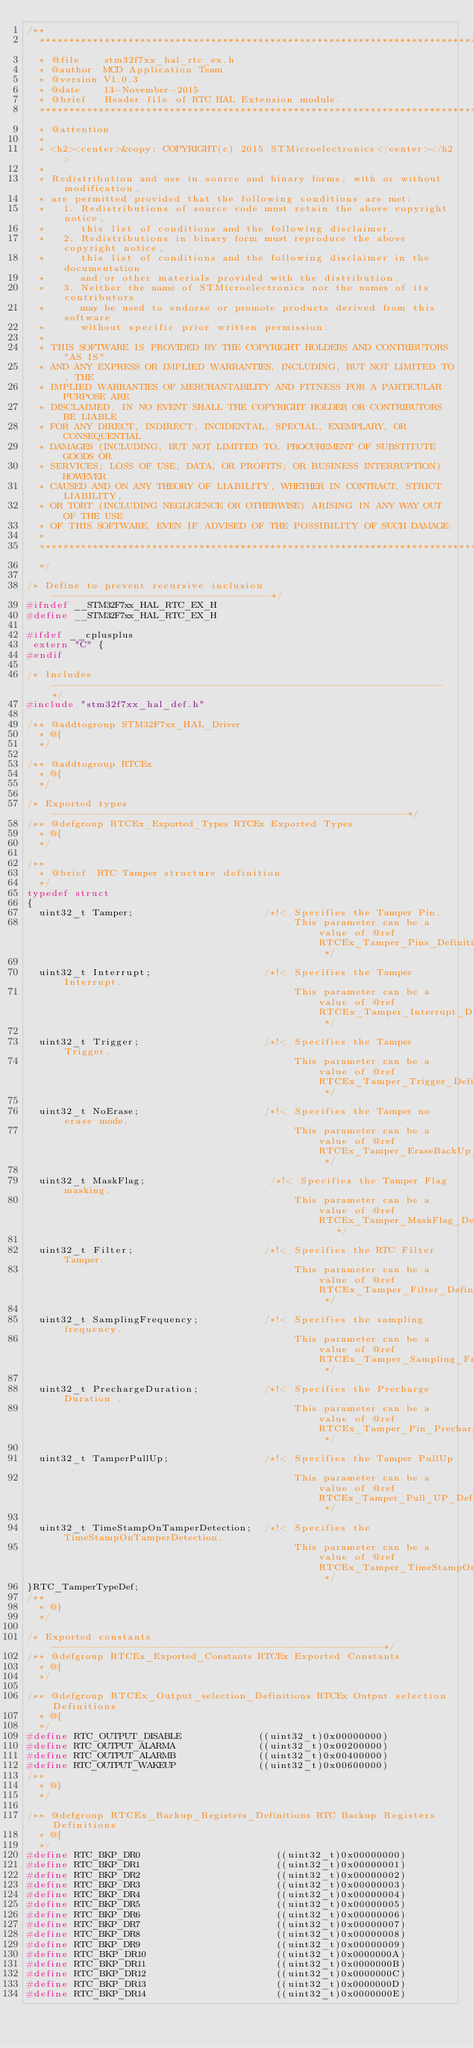<code> <loc_0><loc_0><loc_500><loc_500><_C_>/**
  ******************************************************************************
  * @file    stm32f7xx_hal_rtc_ex.h
  * @author  MCD Application Team
  * @version V1.0.3
  * @date    13-November-2015
  * @brief   Header file of RTC HAL Extension module.
  ******************************************************************************
  * @attention
  *
  * <h2><center>&copy; COPYRIGHT(c) 2015 STMicroelectronics</center></h2>
  *
  * Redistribution and use in source and binary forms, with or without modification,
  * are permitted provided that the following conditions are met:
  *   1. Redistributions of source code must retain the above copyright notice,
  *      this list of conditions and the following disclaimer.
  *   2. Redistributions in binary form must reproduce the above copyright notice,
  *      this list of conditions and the following disclaimer in the documentation
  *      and/or other materials provided with the distribution.
  *   3. Neither the name of STMicroelectronics nor the names of its contributors
  *      may be used to endorse or promote products derived from this software
  *      without specific prior written permission.
  *
  * THIS SOFTWARE IS PROVIDED BY THE COPYRIGHT HOLDERS AND CONTRIBUTORS "AS IS"
  * AND ANY EXPRESS OR IMPLIED WARRANTIES, INCLUDING, BUT NOT LIMITED TO, THE
  * IMPLIED WARRANTIES OF MERCHANTABILITY AND FITNESS FOR A PARTICULAR PURPOSE ARE
  * DISCLAIMED. IN NO EVENT SHALL THE COPYRIGHT HOLDER OR CONTRIBUTORS BE LIABLE
  * FOR ANY DIRECT, INDIRECT, INCIDENTAL, SPECIAL, EXEMPLARY, OR CONSEQUENTIAL
  * DAMAGES (INCLUDING, BUT NOT LIMITED TO, PROCUREMENT OF SUBSTITUTE GOODS OR
  * SERVICES; LOSS OF USE, DATA, OR PROFITS; OR BUSINESS INTERRUPTION) HOWEVER
  * CAUSED AND ON ANY THEORY OF LIABILITY, WHETHER IN CONTRACT, STRICT LIABILITY,
  * OR TORT (INCLUDING NEGLIGENCE OR OTHERWISE) ARISING IN ANY WAY OUT OF THE USE
  * OF THIS SOFTWARE, EVEN IF ADVISED OF THE POSSIBILITY OF SUCH DAMAGE.
  *
  ******************************************************************************
  */ 

/* Define to prevent recursive inclusion -------------------------------------*/
#ifndef __STM32F7xx_HAL_RTC_EX_H
#define __STM32F7xx_HAL_RTC_EX_H

#ifdef __cplusplus
 extern "C" {
#endif

/* Includes ------------------------------------------------------------------*/
#include "stm32f7xx_hal_def.h"

/** @addtogroup STM32F7xx_HAL_Driver
  * @{
  */

/** @addtogroup RTCEx
  * @{
  */ 

/* Exported types ------------------------------------------------------------*/ 
/** @defgroup RTCEx_Exported_Types RTCEx Exported Types
  * @{
  */

/** 
  * @brief  RTC Tamper structure definition  
  */
typedef struct 
{
  uint32_t Tamper;                      /*!< Specifies the Tamper Pin.
                                             This parameter can be a value of @ref  RTCEx_Tamper_Pins_Definitions */
  
  uint32_t Interrupt;                   /*!< Specifies the Tamper Interrupt.
                                             This parameter can be a value of @ref  RTCEx_Tamper_Interrupt_Definitions */                                  
                                             
  uint32_t Trigger;                     /*!< Specifies the Tamper Trigger.
                                             This parameter can be a value of @ref  RTCEx_Tamper_Trigger_Definitions */
                                             
  uint32_t NoErase;                     /*!< Specifies the Tamper no erase mode.
                                             This parameter can be a value of @ref  RTCEx_Tamper_EraseBackUp_Definitions */

  uint32_t MaskFlag;                     /*!< Specifies the Tamper Flag masking.
                                             This parameter can be a value of @ref RTCEx_Tamper_MaskFlag_Definitions   */

  uint32_t Filter;                      /*!< Specifies the RTC Filter Tamper.
                                             This parameter can be a value of @ref RTCEx_Tamper_Filter_Definitions */
  
  uint32_t SamplingFrequency;           /*!< Specifies the sampling frequency.
                                             This parameter can be a value of @ref RTCEx_Tamper_Sampling_Frequencies_Definitions */
                                      
  uint32_t PrechargeDuration;           /*!< Specifies the Precharge Duration .
                                             This parameter can be a value of @ref RTCEx_Tamper_Pin_Precharge_Duration_Definitions */ 
 
  uint32_t TamperPullUp;                /*!< Specifies the Tamper PullUp .
                                             This parameter can be a value of @ref RTCEx_Tamper_Pull_UP_Definitions */           
 
  uint32_t TimeStampOnTamperDetection;  /*!< Specifies the TimeStampOnTamperDetection.
                                             This parameter can be a value of @ref RTCEx_Tamper_TimeStampOnTamperDetection_Definitions */                      
}RTC_TamperTypeDef;
/**
  * @}
  */

/* Exported constants --------------------------------------------------------*/
/** @defgroup RTCEx_Exported_Constants RTCEx Exported Constants
  * @{
  */

/** @defgroup RTCEx_Output_selection_Definitions RTCEx Output selection Definitions 
  * @{
  */ 
#define RTC_OUTPUT_DISABLE             ((uint32_t)0x00000000)
#define RTC_OUTPUT_ALARMA              ((uint32_t)0x00200000)
#define RTC_OUTPUT_ALARMB              ((uint32_t)0x00400000)
#define RTC_OUTPUT_WAKEUP              ((uint32_t)0x00600000)
/**
  * @}
  */ 
  
/** @defgroup RTCEx_Backup_Registers_Definitions RTC Backup Registers Definitions
  * @{
  */
#define RTC_BKP_DR0                       ((uint32_t)0x00000000)
#define RTC_BKP_DR1                       ((uint32_t)0x00000001)
#define RTC_BKP_DR2                       ((uint32_t)0x00000002)
#define RTC_BKP_DR3                       ((uint32_t)0x00000003)
#define RTC_BKP_DR4                       ((uint32_t)0x00000004)
#define RTC_BKP_DR5                       ((uint32_t)0x00000005)
#define RTC_BKP_DR6                       ((uint32_t)0x00000006)
#define RTC_BKP_DR7                       ((uint32_t)0x00000007)
#define RTC_BKP_DR8                       ((uint32_t)0x00000008)
#define RTC_BKP_DR9                       ((uint32_t)0x00000009)
#define RTC_BKP_DR10                      ((uint32_t)0x0000000A)
#define RTC_BKP_DR11                      ((uint32_t)0x0000000B)
#define RTC_BKP_DR12                      ((uint32_t)0x0000000C)
#define RTC_BKP_DR13                      ((uint32_t)0x0000000D)
#define RTC_BKP_DR14                      ((uint32_t)0x0000000E)</code> 